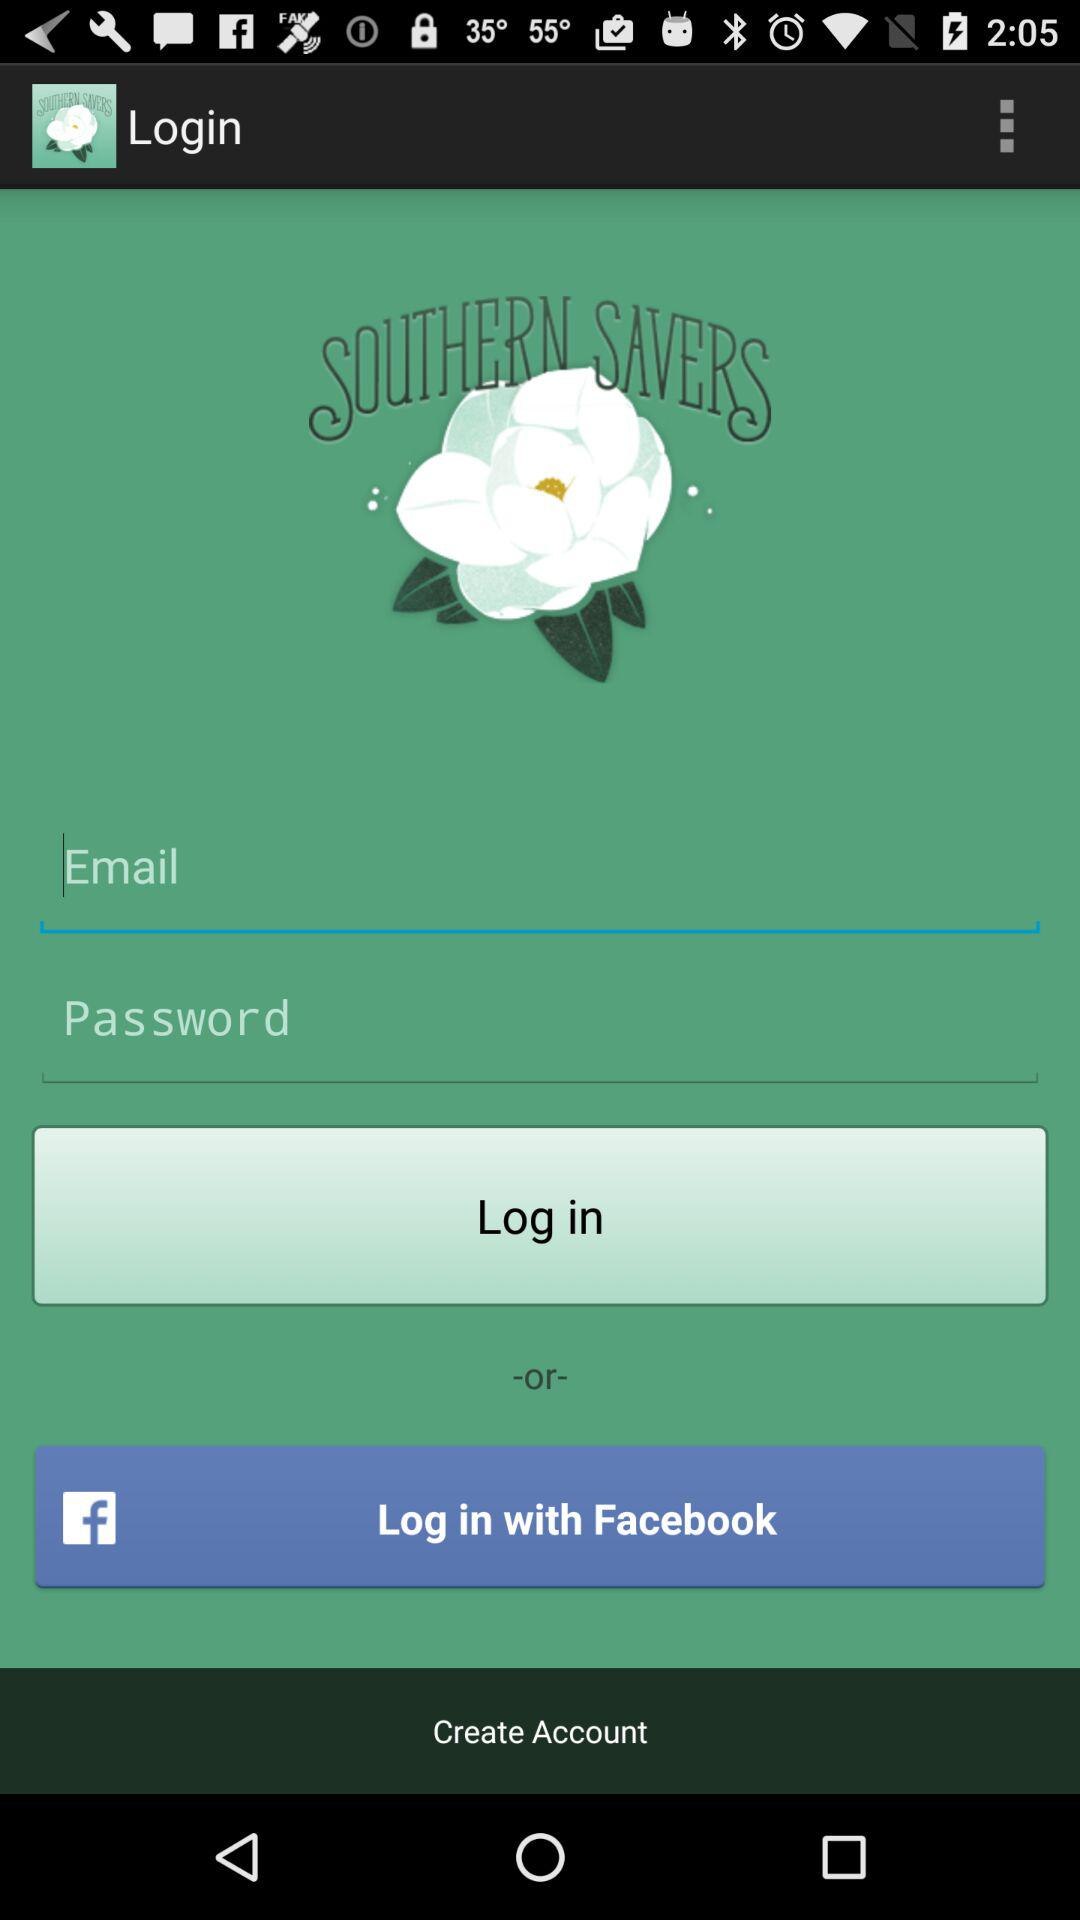What is the name of application? The name of the application is "SOUTHERN SAVERS". 